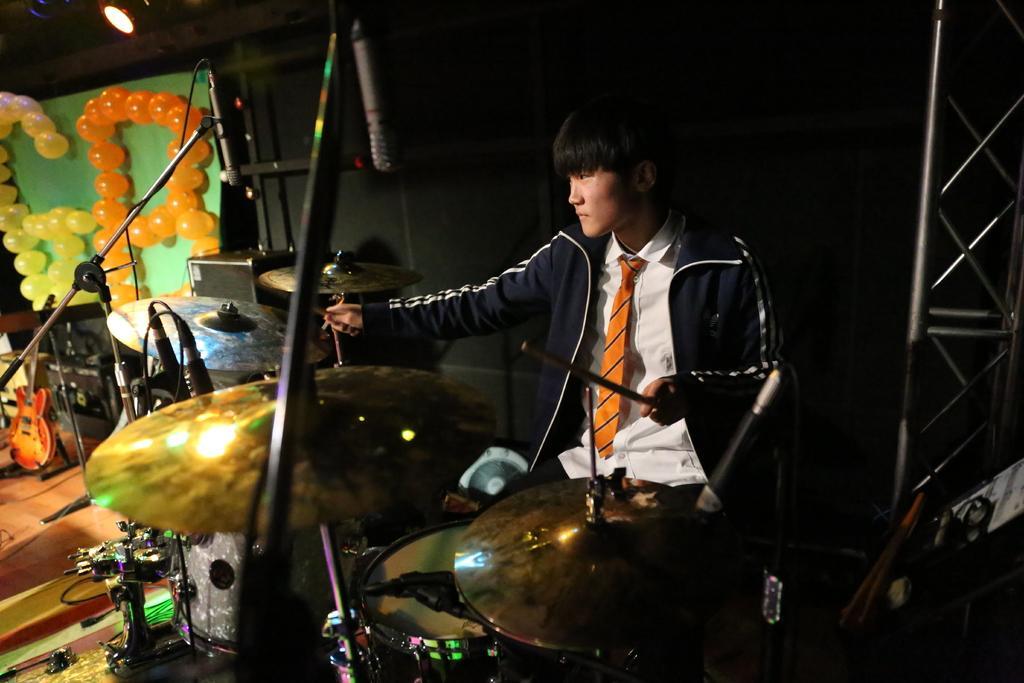Could you give a brief overview of what you see in this image? In the image we can see a man sitting, wearing clothes and holding drumsticks in hands. In front of him we can see musical instruments, microphones and cable wires. Here we can see balloons, floor, fence and light. 